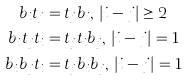Convert formula to latex. <formula><loc_0><loc_0><loc_500><loc_500>b _ { i } t _ { j } & = t _ { j } b _ { i } , \, \left | i - j \right | \geq 2 \\ b _ { i } t _ { j } t _ { i } & = t _ { j } t _ { i } b _ { j } , \, \left | i - j \right | = 1 \\ b _ { i } b _ { j } t _ { i } & = t _ { j } b _ { i } b _ { j } , \, \left | i - j \right | = 1 \,</formula> 